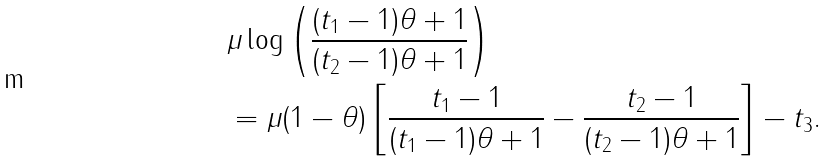<formula> <loc_0><loc_0><loc_500><loc_500>& \mu \log \left ( \frac { ( t _ { 1 } - 1 ) \theta + 1 } { ( t _ { 2 } - 1 ) \theta + 1 } \right ) \\ & = \mu ( 1 - \theta ) \left [ \frac { t _ { 1 } - 1 } { ( t _ { 1 } - 1 ) \theta + 1 } - \frac { t _ { 2 } - 1 } { ( t _ { 2 } - 1 ) \theta + 1 } \right ] - t _ { 3 } .</formula> 